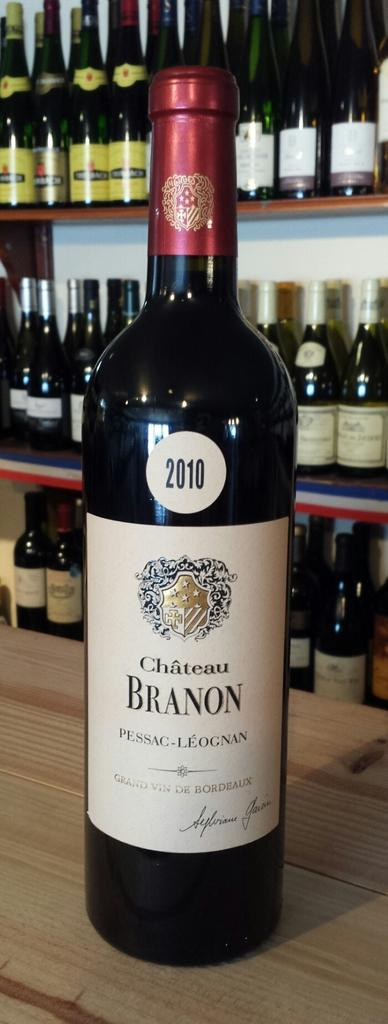<image>
Offer a succinct explanation of the picture presented. A bottle of Chateau Branon wine with the year 2010 label at the top. 